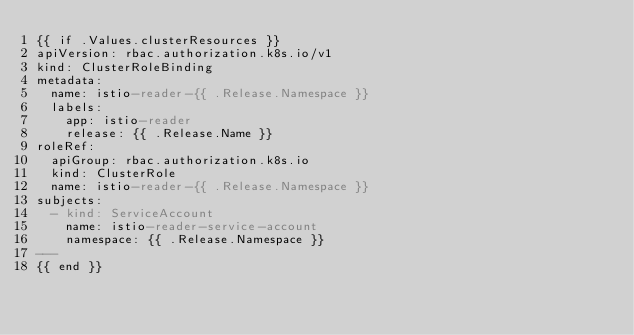<code> <loc_0><loc_0><loc_500><loc_500><_YAML_>{{ if .Values.clusterResources }}
apiVersion: rbac.authorization.k8s.io/v1
kind: ClusterRoleBinding
metadata:
  name: istio-reader-{{ .Release.Namespace }}
  labels:
    app: istio-reader
    release: {{ .Release.Name }}
roleRef:
  apiGroup: rbac.authorization.k8s.io
  kind: ClusterRole
  name: istio-reader-{{ .Release.Namespace }}
subjects:
  - kind: ServiceAccount
    name: istio-reader-service-account
    namespace: {{ .Release.Namespace }}
---
{{ end }}
</code> 